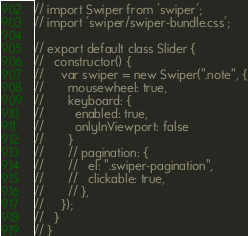<code> <loc_0><loc_0><loc_500><loc_500><_JavaScript_>// import Swiper from 'swiper';
// import 'swiper/swiper-bundle.css';

// export default class Slider {
//   constructor() {
//     var swiper = new Swiper(".note", {
//       mousewheel: true,
//       keyboard: {
//         enabled: true,
//         onlyInViewport: false
//       }
//       // pagination: {
//       //   el: ".swiper-pagination",
//       //   clickable: true,
//       // },
//     });
//   }
// }
</code> 